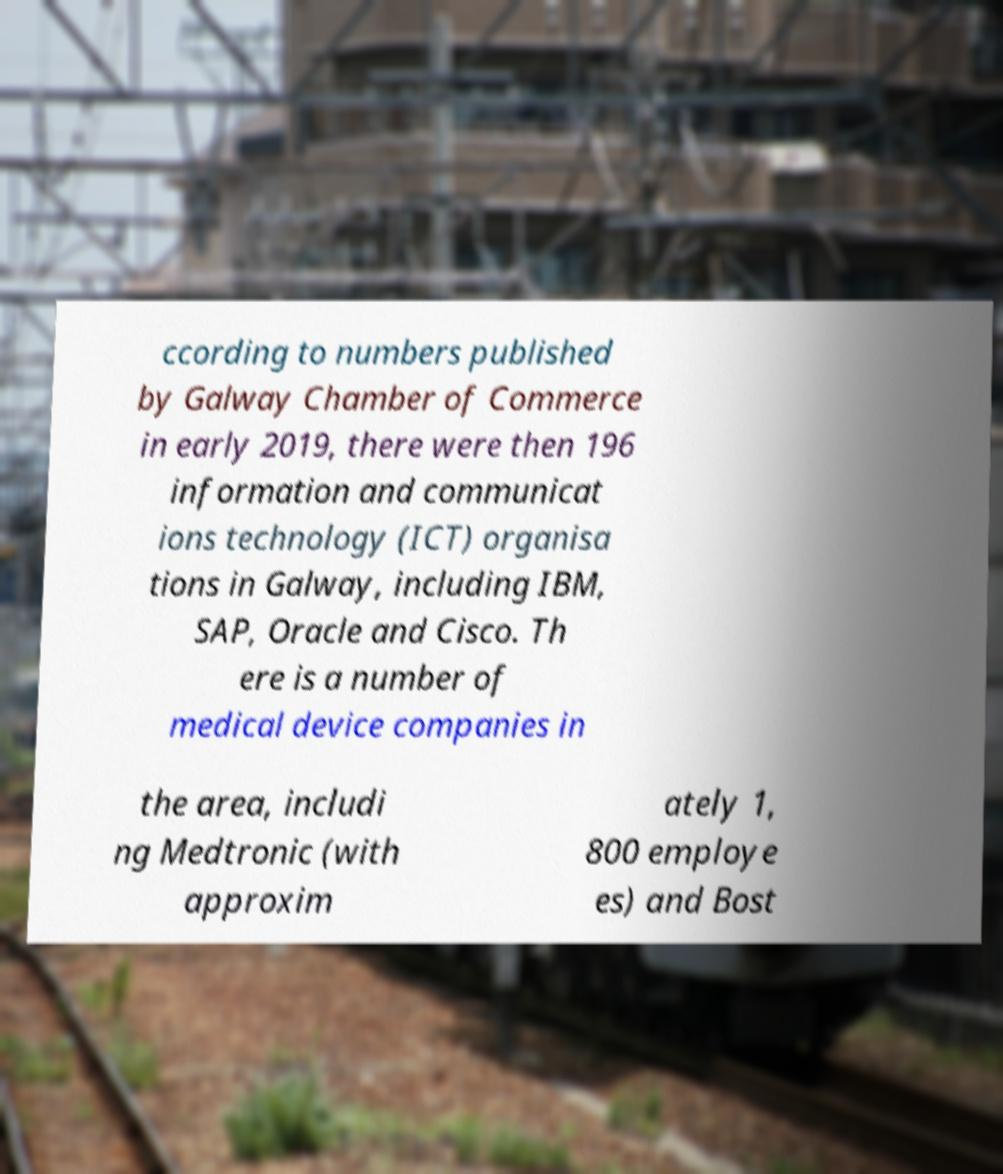Please identify and transcribe the text found in this image. ccording to numbers published by Galway Chamber of Commerce in early 2019, there were then 196 information and communicat ions technology (ICT) organisa tions in Galway, including IBM, SAP, Oracle and Cisco. Th ere is a number of medical device companies in the area, includi ng Medtronic (with approxim ately 1, 800 employe es) and Bost 